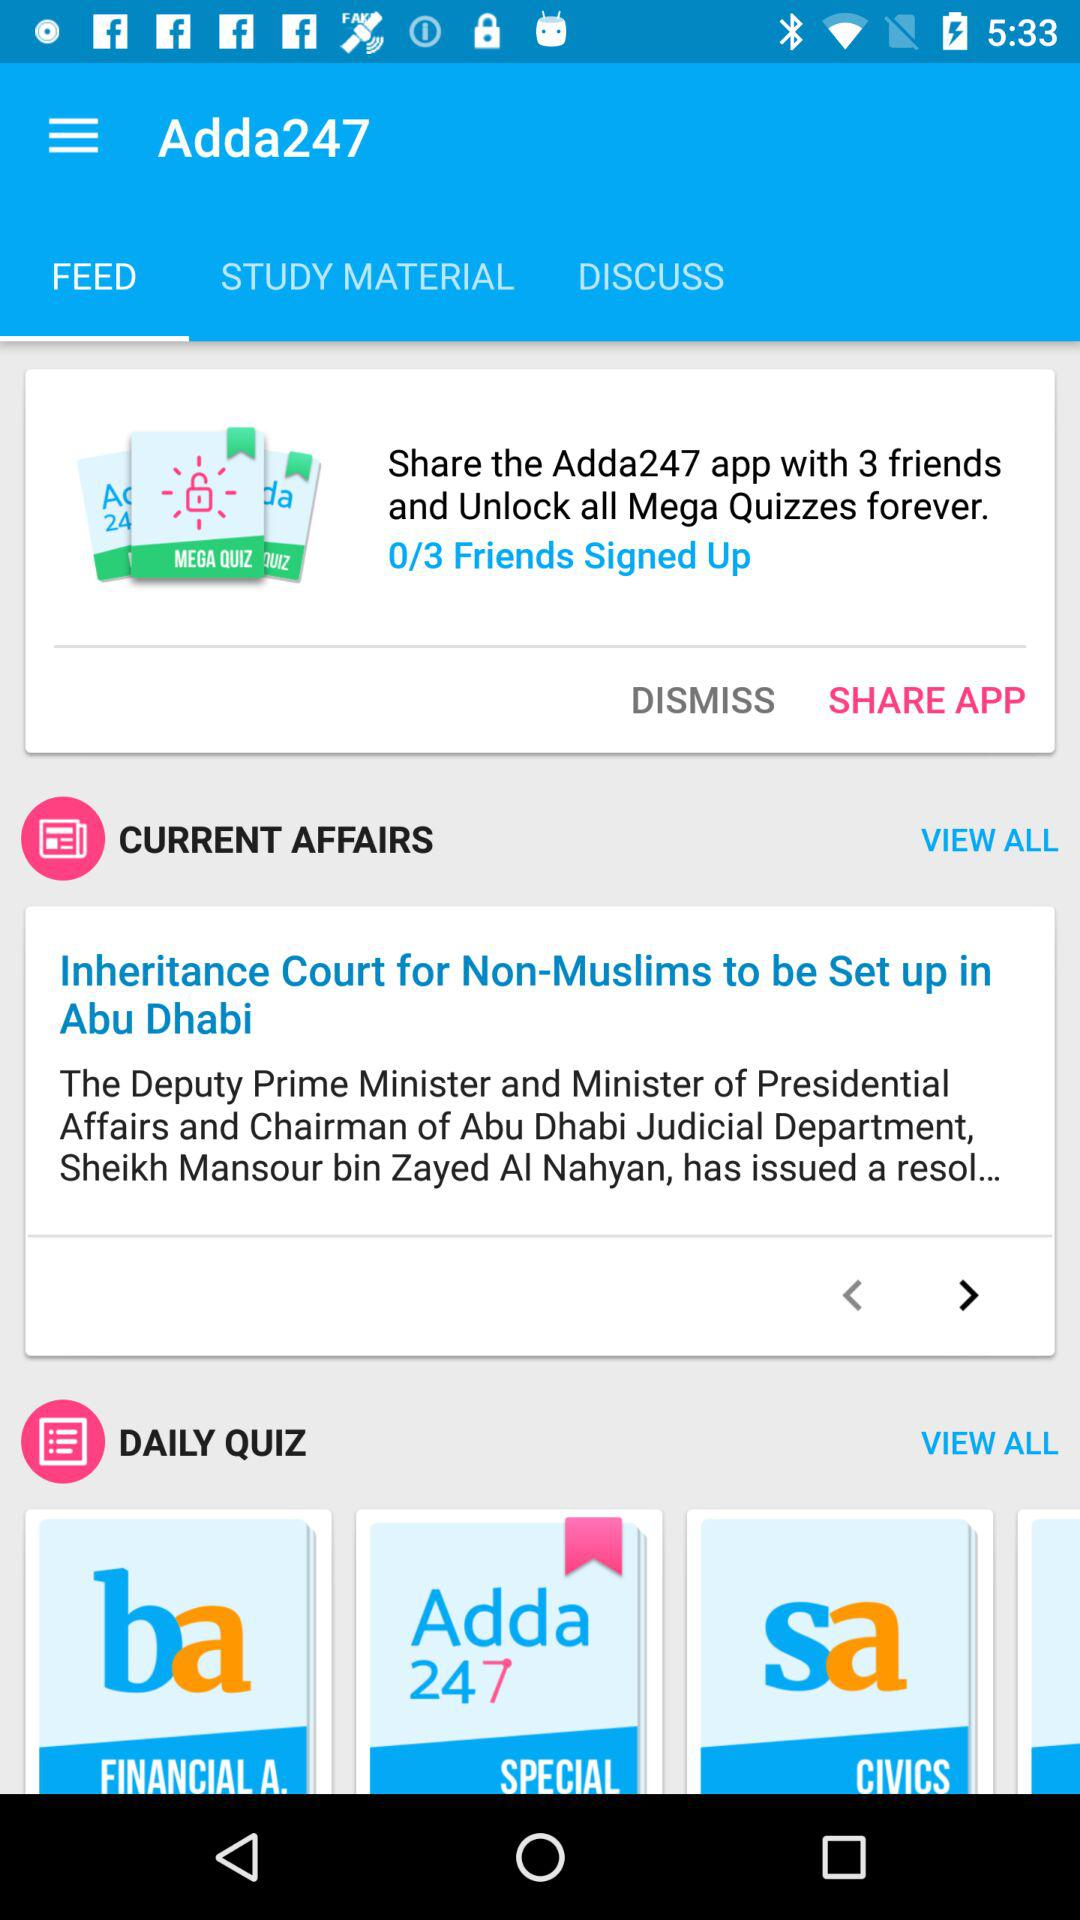Which tab is selected? The selected tab is "FEED". 